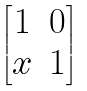Convert formula to latex. <formula><loc_0><loc_0><loc_500><loc_500>\begin{bmatrix} 1 & 0 \\ x & 1 \end{bmatrix}</formula> 